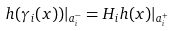Convert formula to latex. <formula><loc_0><loc_0><loc_500><loc_500>h ( \gamma _ { i } ( x ) ) | _ { a _ { i } ^ { - } } = H _ { i } h ( x ) | _ { a ^ { + } _ { i } }</formula> 